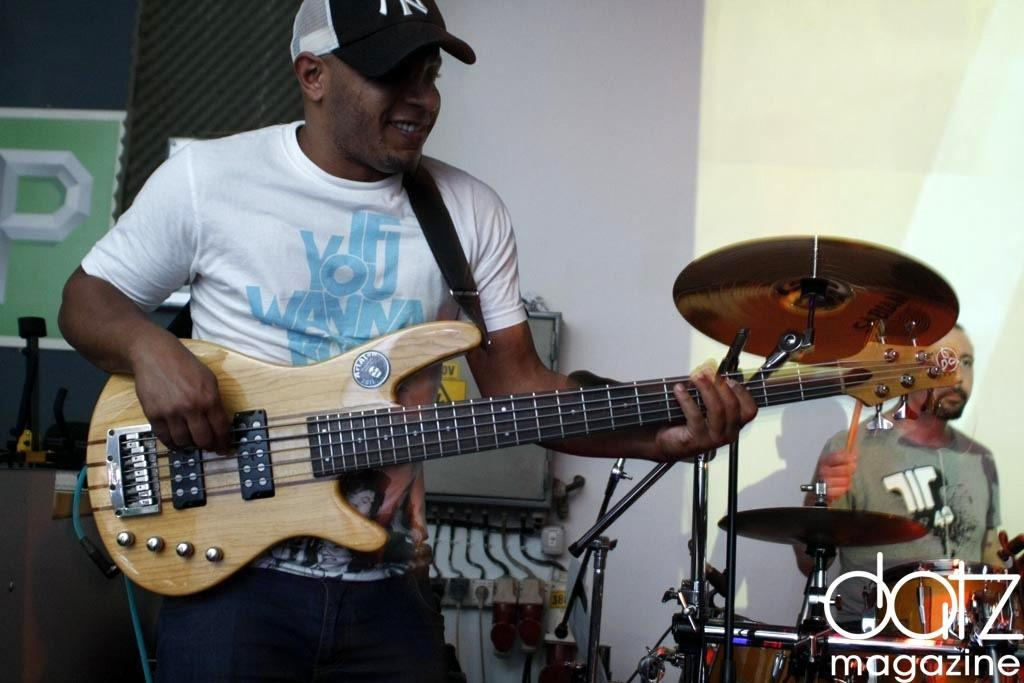What is the man in the front doing in the image? The man in the front is holding a guitar. What is the man in the back doing in the image? The man in the back is at the back of the drums. Can you describe the musical instruments in the image? There is a guitar and a drum set in the image. What type of woodworking tools can be seen in the image? There are no woodworking tools present in the image; it features a man holding a guitar and another man at the back of the drums. 